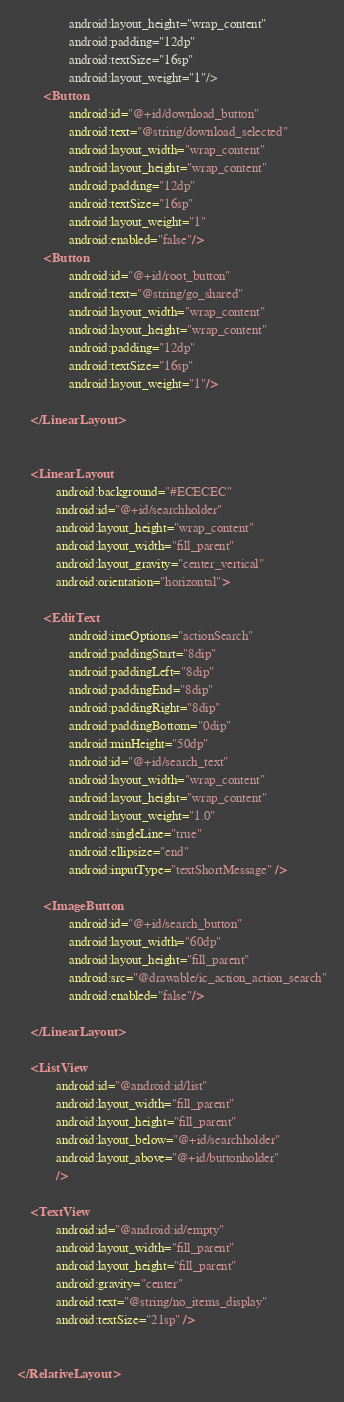Convert code to text. <code><loc_0><loc_0><loc_500><loc_500><_XML_>                android:layout_height="wrap_content"
                android:padding="12dp"
                android:textSize="16sp"
                android:layout_weight="1"/>
        <Button
                android:id="@+id/download_button"
                android:text="@string/download_selected"
                android:layout_width="wrap_content"
                android:layout_height="wrap_content"
                android:padding="12dp"
                android:textSize="16sp"
                android:layout_weight="1"
                android:enabled="false"/>
        <Button
                android:id="@+id/root_button"
                android:text="@string/go_shared"
                android:layout_width="wrap_content"
                android:layout_height="wrap_content"
                android:padding="12dp"
                android:textSize="16sp"
                android:layout_weight="1"/>

    </LinearLayout>


    <LinearLayout
            android:background="#ECECEC"
            android:id="@+id/searchholder"
            android:layout_height="wrap_content"
            android:layout_width="fill_parent"
            android:layout_gravity="center_vertical"
            android:orientation="horizontal">

        <EditText
                android:imeOptions="actionSearch"
				android:paddingStart="8dip"
                android:paddingLeft="8dip"
				android:paddingEnd="8dip"
                android:paddingRight="8dip"
                android:paddingBottom="0dip"
                android:minHeight="50dp"
                android:id="@+id/search_text"
                android:layout_width="wrap_content"
                android:layout_height="wrap_content"
                android:layout_weight="1.0"
                android:singleLine="true"
                android:ellipsize="end"
                android:inputType="textShortMessage" />

        <ImageButton
                android:id="@+id/search_button"
                android:layout_width="60dp"
                android:layout_height="fill_parent"
                android:src="@drawable/ic_action_action_search"
                android:enabled="false"/>

    </LinearLayout>

    <ListView
            android:id="@android:id/list"
            android:layout_width="fill_parent"
            android:layout_height="fill_parent"
            android:layout_below="@+id/searchholder"
            android:layout_above="@+id/buttonholder"
            />

    <TextView
            android:id="@android:id/empty"
            android:layout_width="fill_parent"
            android:layout_height="fill_parent"
            android:gravity="center"
            android:text="@string/no_items_display"
            android:textSize="21sp" />


</RelativeLayout></code> 